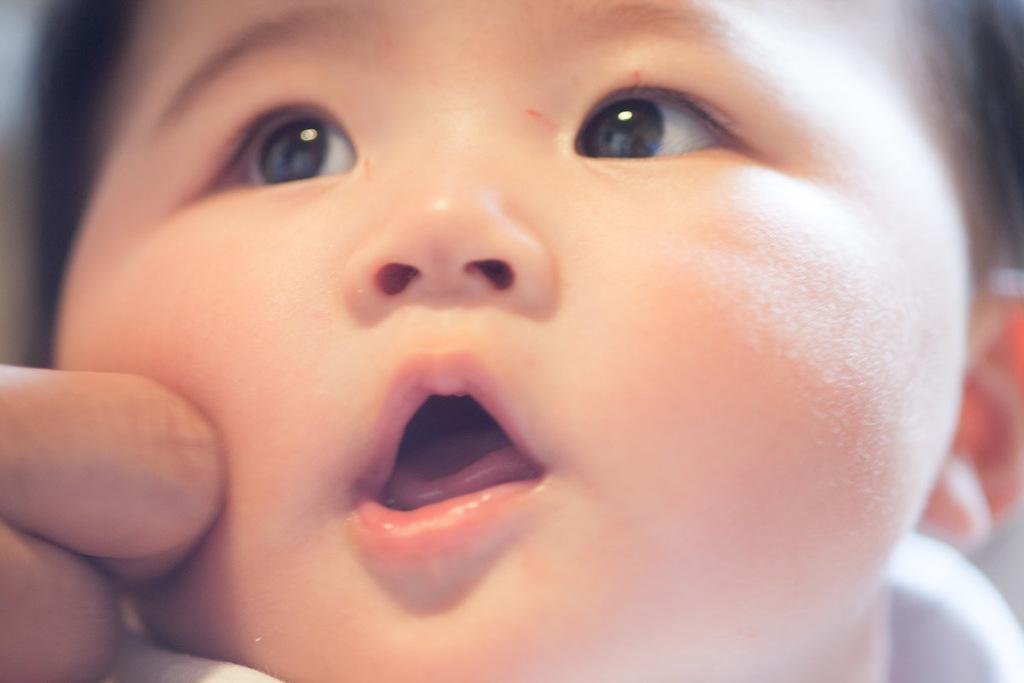What is the main subject of the image? The main subject of the image is a small kid. Can you describe any other elements in the image? Yes, there are a person's fingers on the left side of the image. What type of agreement is being signed by the kid in the image? There is no indication in the image that the kid is signing any agreement. 